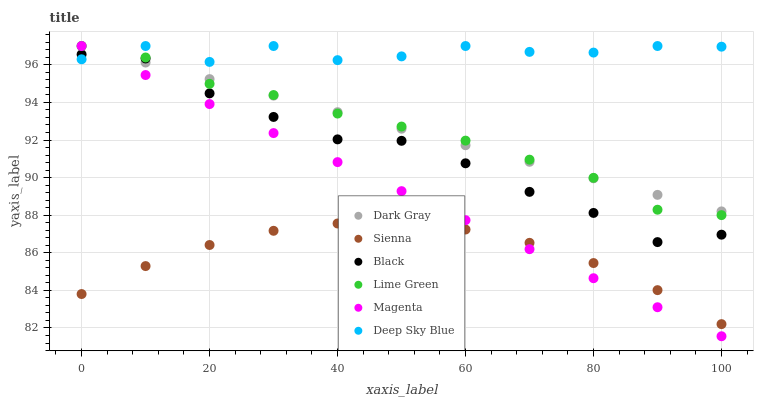Does Sienna have the minimum area under the curve?
Answer yes or no. Yes. Does Deep Sky Blue have the maximum area under the curve?
Answer yes or no. Yes. Does Dark Gray have the minimum area under the curve?
Answer yes or no. No. Does Dark Gray have the maximum area under the curve?
Answer yes or no. No. Is Dark Gray the smoothest?
Answer yes or no. Yes. Is Deep Sky Blue the roughest?
Answer yes or no. Yes. Is Black the smoothest?
Answer yes or no. No. Is Black the roughest?
Answer yes or no. No. Does Magenta have the lowest value?
Answer yes or no. Yes. Does Dark Gray have the lowest value?
Answer yes or no. No. Does Lime Green have the highest value?
Answer yes or no. Yes. Does Black have the highest value?
Answer yes or no. No. Is Sienna less than Deep Sky Blue?
Answer yes or no. Yes. Is Black greater than Sienna?
Answer yes or no. Yes. Does Magenta intersect Black?
Answer yes or no. Yes. Is Magenta less than Black?
Answer yes or no. No. Is Magenta greater than Black?
Answer yes or no. No. Does Sienna intersect Deep Sky Blue?
Answer yes or no. No. 